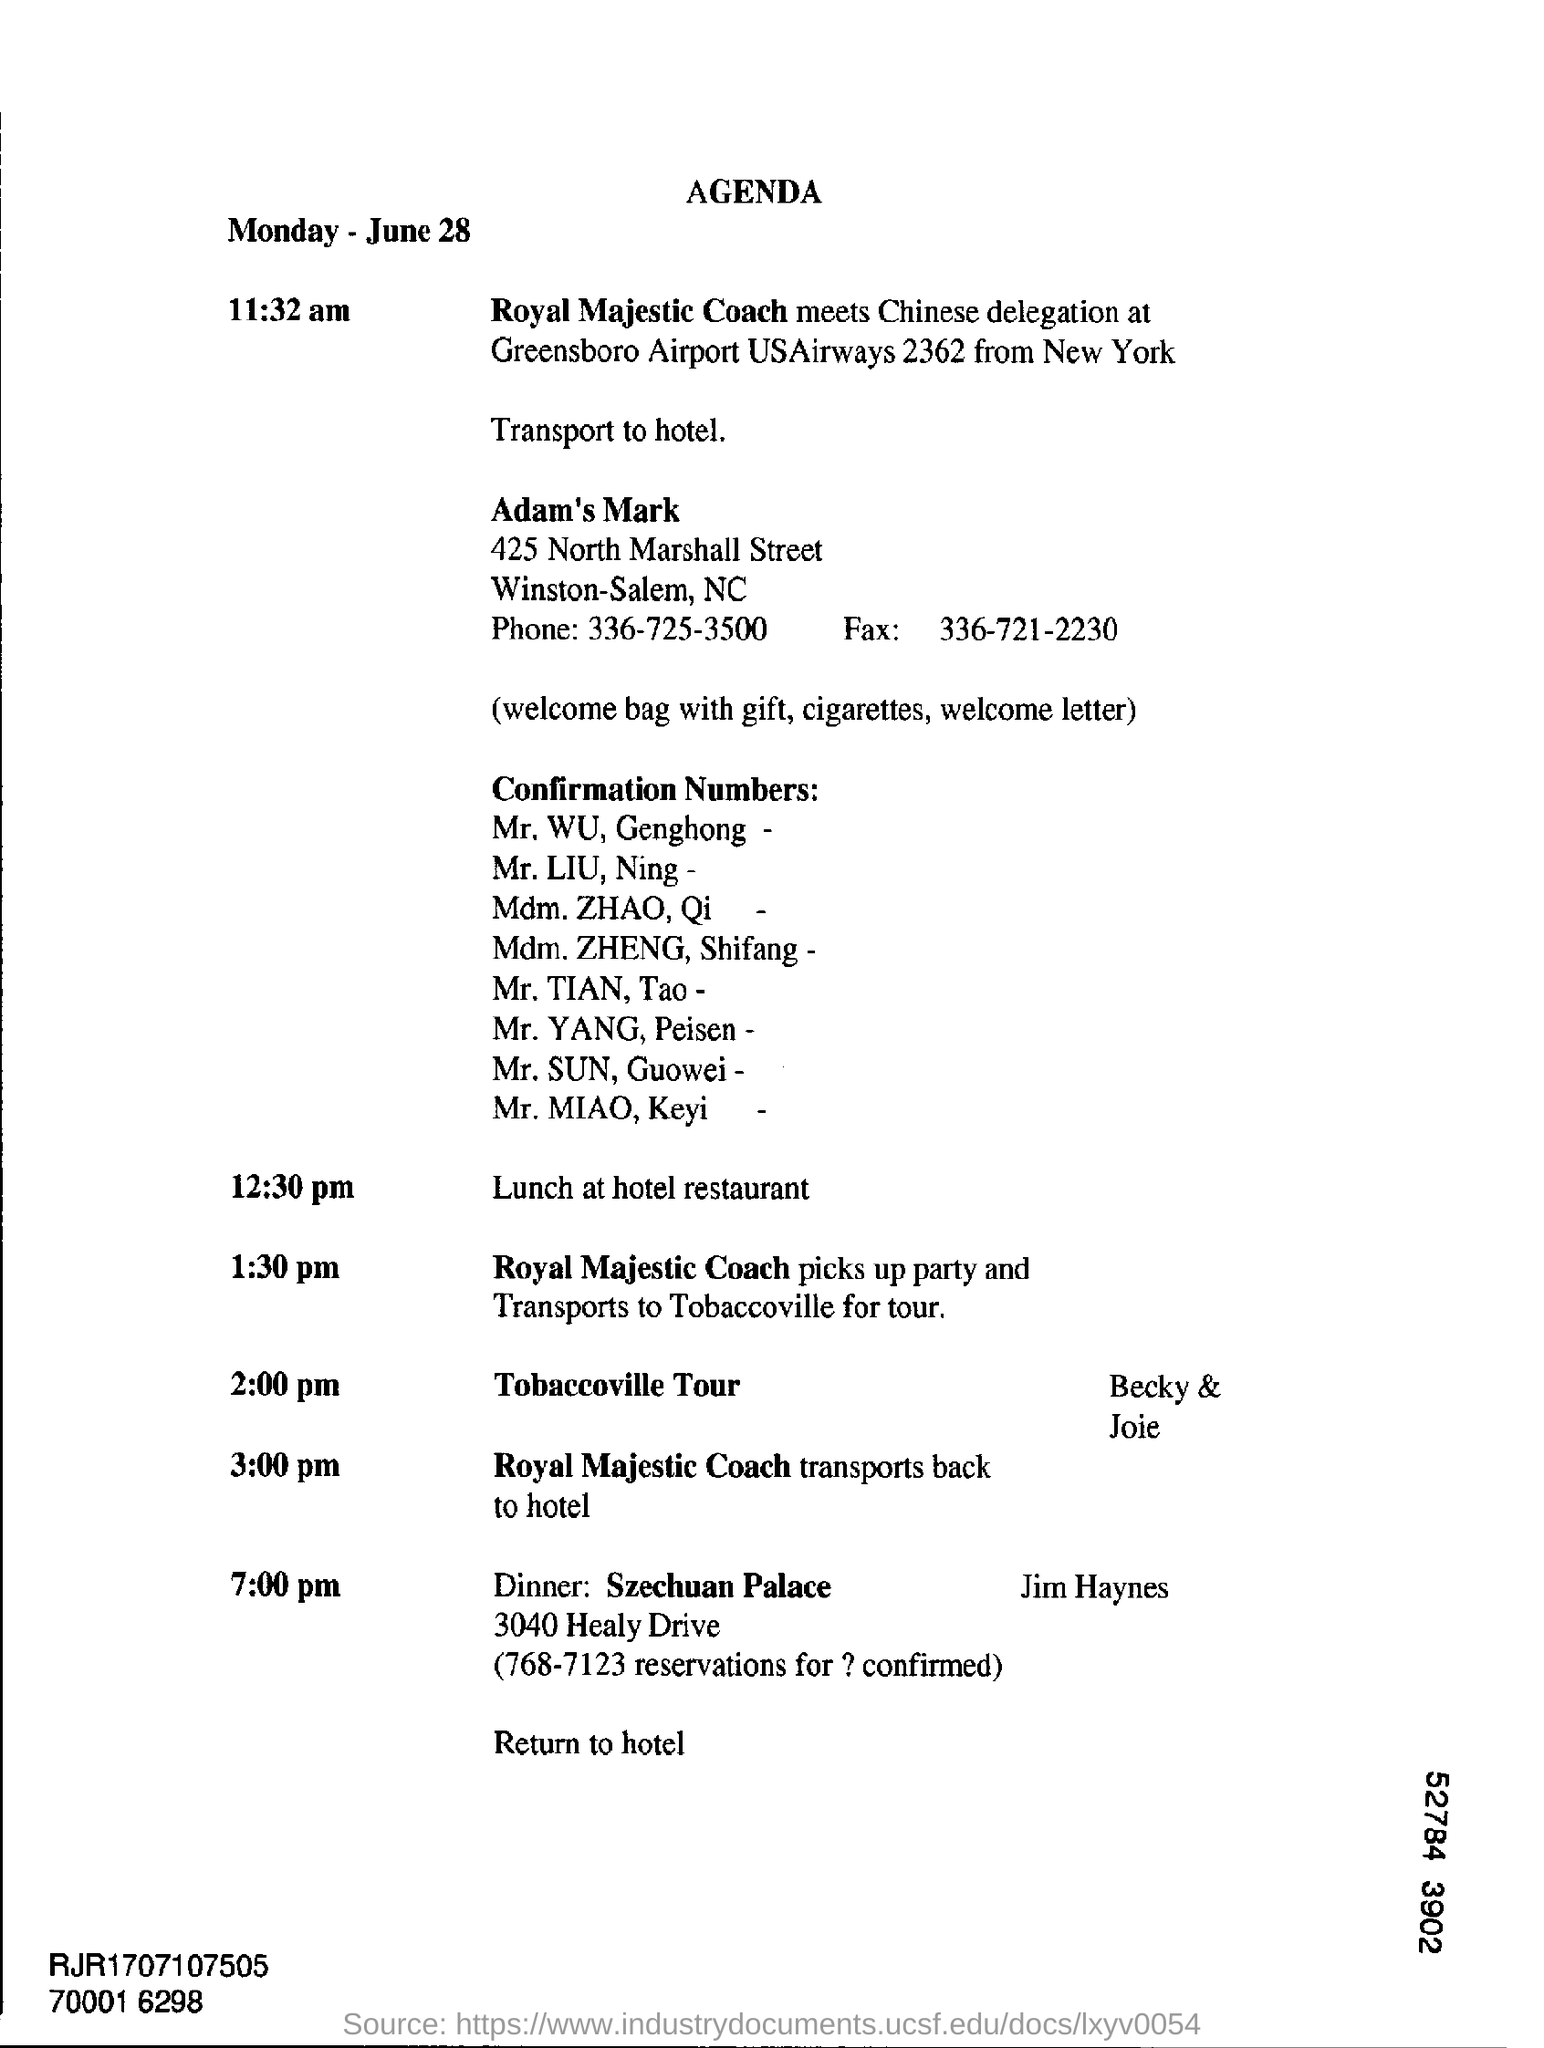What is the schedule at 12:30 pm?
Give a very brief answer. Lunch at hotel restaurant. 